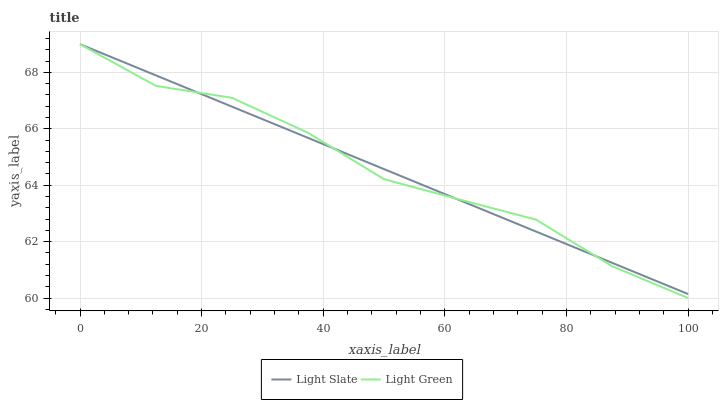Does Light Slate have the minimum area under the curve?
Answer yes or no. Yes. Does Light Green have the maximum area under the curve?
Answer yes or no. Yes. Does Light Green have the minimum area under the curve?
Answer yes or no. No. Is Light Slate the smoothest?
Answer yes or no. Yes. Is Light Green the roughest?
Answer yes or no. Yes. Is Light Green the smoothest?
Answer yes or no. No. Does Light Green have the lowest value?
Answer yes or no. Yes. Does Light Green have the highest value?
Answer yes or no. Yes. Does Light Green intersect Light Slate?
Answer yes or no. Yes. Is Light Green less than Light Slate?
Answer yes or no. No. Is Light Green greater than Light Slate?
Answer yes or no. No. 